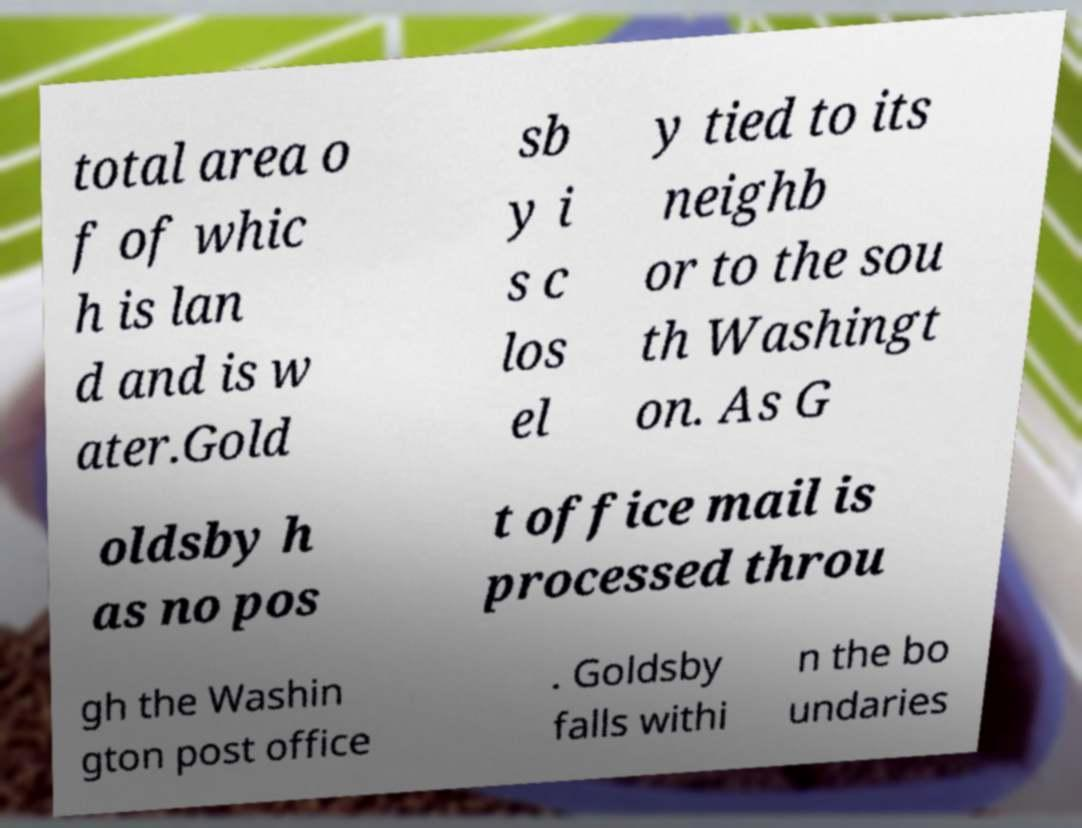I need the written content from this picture converted into text. Can you do that? total area o f of whic h is lan d and is w ater.Gold sb y i s c los el y tied to its neighb or to the sou th Washingt on. As G oldsby h as no pos t office mail is processed throu gh the Washin gton post office . Goldsby falls withi n the bo undaries 